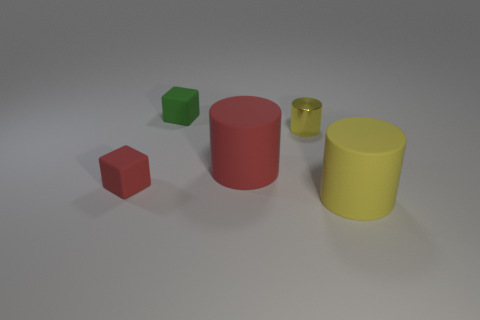Is the color of the small cylinder the same as the matte thing that is right of the yellow metal cylinder?
Provide a short and direct response. Yes. How many other things are the same size as the green matte thing?
Ensure brevity in your answer.  2. Are the small red thing and the red thing that is right of the small green matte block made of the same material?
Offer a terse response. Yes. Are there an equal number of red objects on the right side of the small shiny thing and small yellow metallic things that are on the right side of the red cylinder?
Make the answer very short. No. What is the small yellow cylinder made of?
Your answer should be compact. Metal. There is another matte cylinder that is the same size as the red rubber cylinder; what color is it?
Keep it short and to the point. Yellow. Is there a large red thing behind the big thing in front of the small red object?
Offer a terse response. Yes. What number of cylinders are small brown rubber objects or big yellow objects?
Keep it short and to the point. 1. What size is the rubber cylinder behind the large matte cylinder that is right of the cylinder that is behind the big red rubber object?
Make the answer very short. Large. Are there any cylinders behind the red cylinder?
Your answer should be very brief. Yes. 